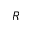Convert formula to latex. <formula><loc_0><loc_0><loc_500><loc_500>R</formula> 